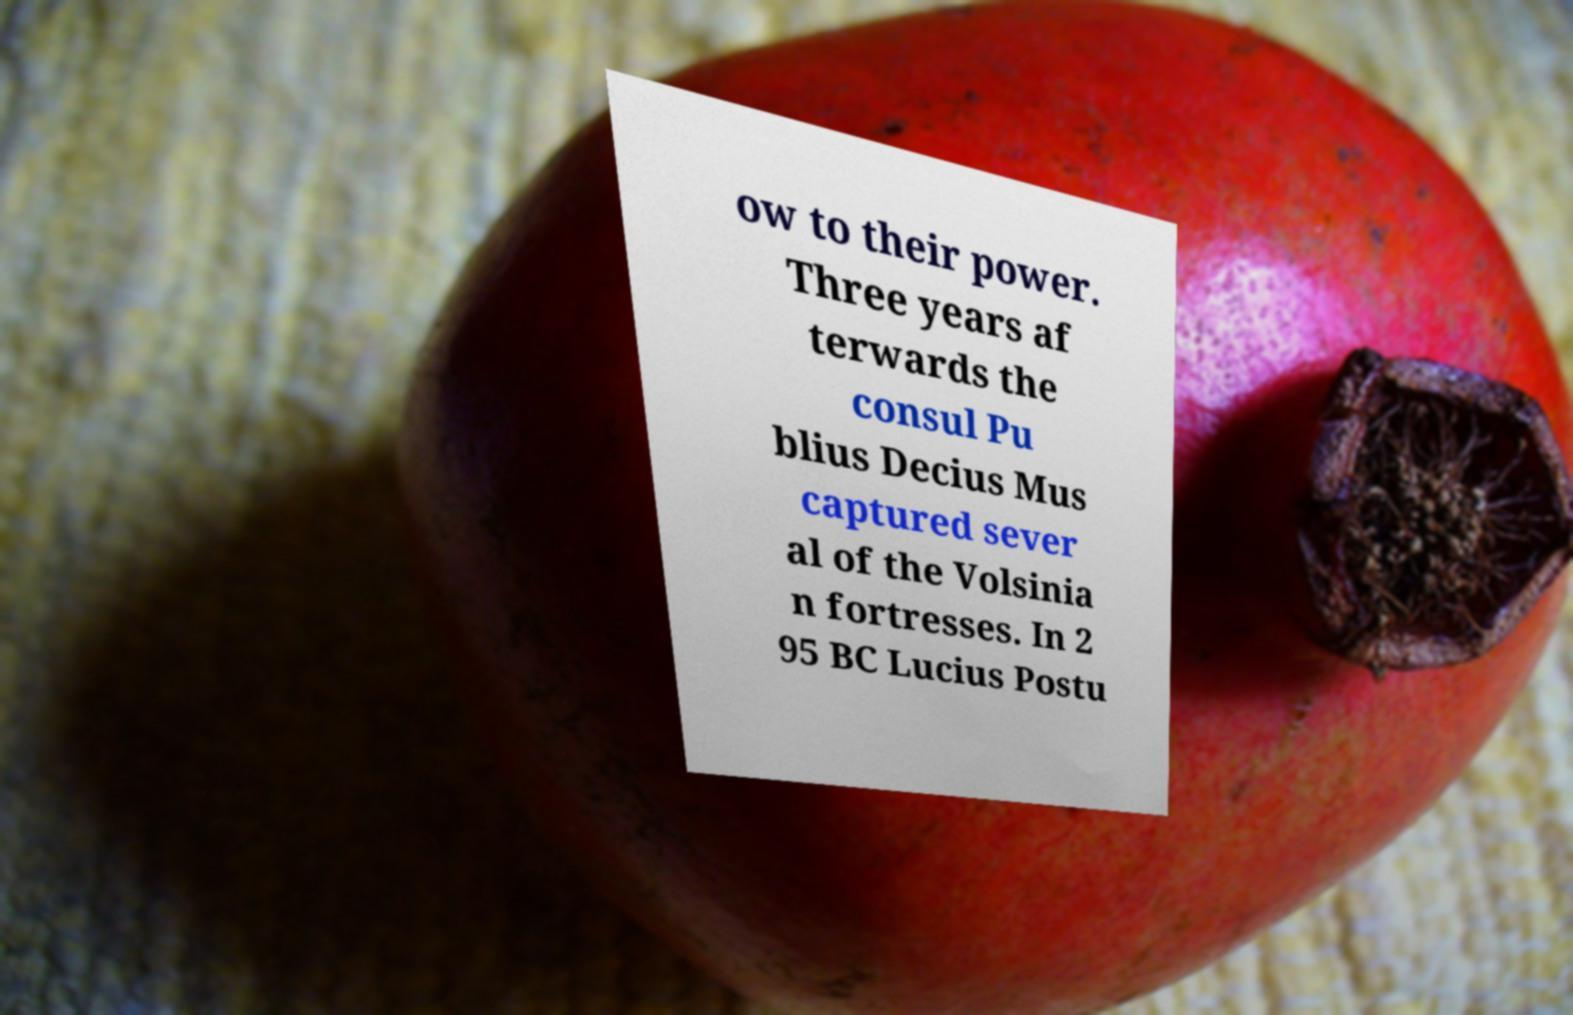There's text embedded in this image that I need extracted. Can you transcribe it verbatim? ow to their power. Three years af terwards the consul Pu blius Decius Mus captured sever al of the Volsinia n fortresses. In 2 95 BC Lucius Postu 